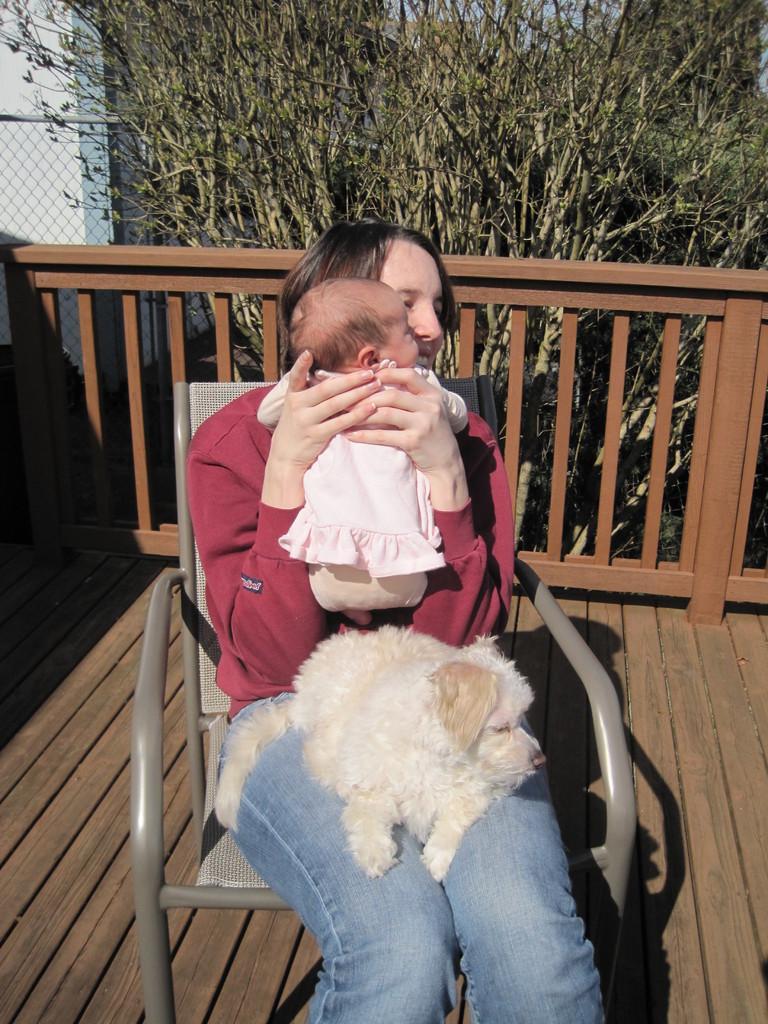Could you give a brief overview of what you see in this image? This image is clicked outside. There is a tree on the top and there is a chair in the middle on which a woman is sitting. She is holding a baby in her hand and she also has a dog on her lap. She is wearing red color t-shirt and blue color jeans. 